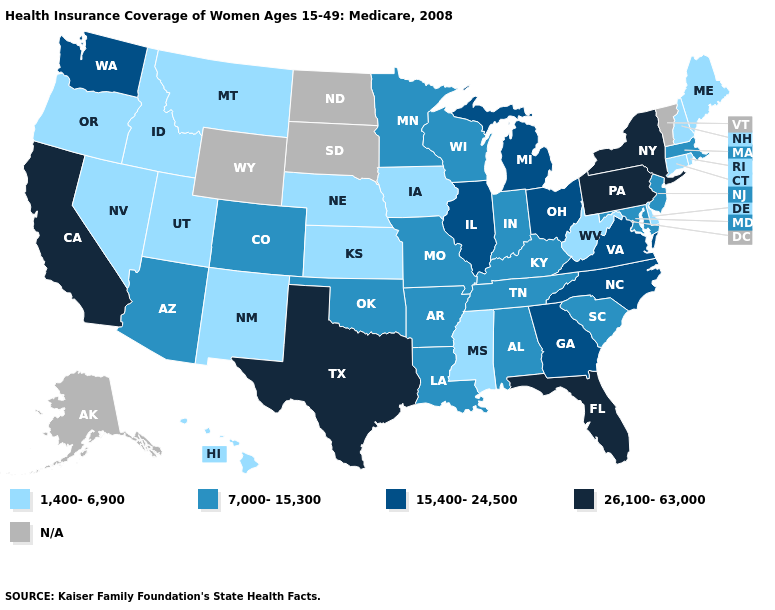What is the highest value in states that border Rhode Island?
Concise answer only. 7,000-15,300. What is the value of Missouri?
Keep it brief. 7,000-15,300. Does New Mexico have the highest value in the USA?
Quick response, please. No. What is the highest value in the South ?
Keep it brief. 26,100-63,000. Does Kentucky have the lowest value in the USA?
Keep it brief. No. Does Delaware have the highest value in the South?
Concise answer only. No. What is the value of North Dakota?
Keep it brief. N/A. Does Oregon have the lowest value in the West?
Concise answer only. Yes. What is the highest value in the MidWest ?
Quick response, please. 15,400-24,500. What is the value of Michigan?
Answer briefly. 15,400-24,500. Which states hav the highest value in the Northeast?
Keep it brief. New York, Pennsylvania. Name the states that have a value in the range N/A?
Concise answer only. Alaska, North Dakota, South Dakota, Vermont, Wyoming. What is the lowest value in the USA?
Concise answer only. 1,400-6,900. Is the legend a continuous bar?
Concise answer only. No. 